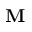<formula> <loc_0><loc_0><loc_500><loc_500>M</formula> 